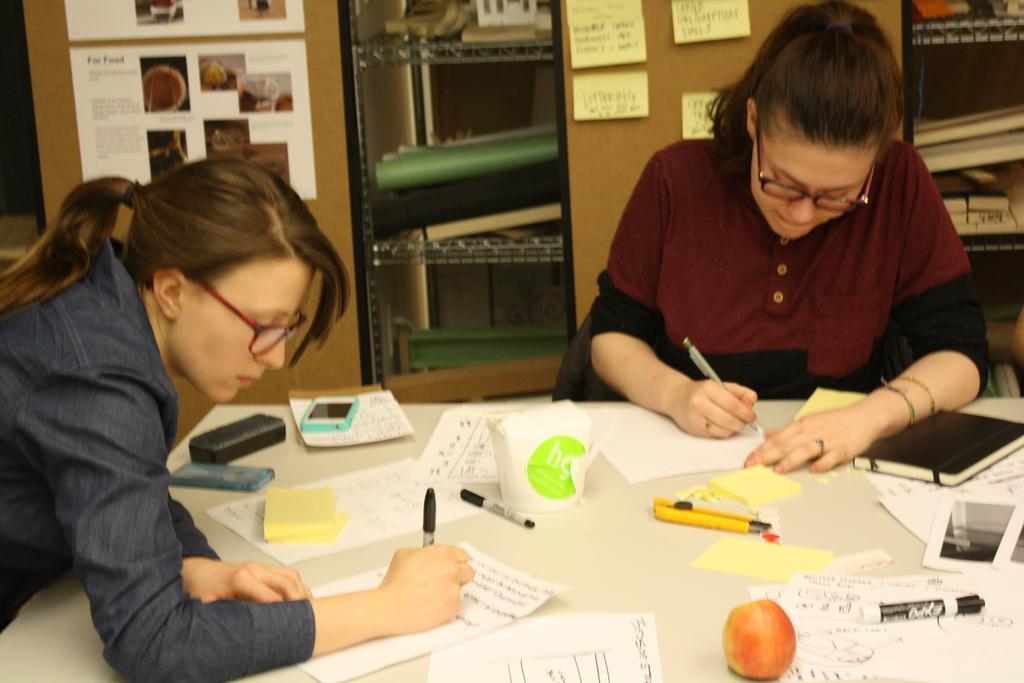Please provide a concise description of this image. In this image, there are two women sitting on the chairs and writing on the papers. At the bottom of the image, I can see an apple, mobiles, papers, pens, a book and few other objects on a table. In the background, I can see the posts attached to an object and there are books and few other objects in the racks. 